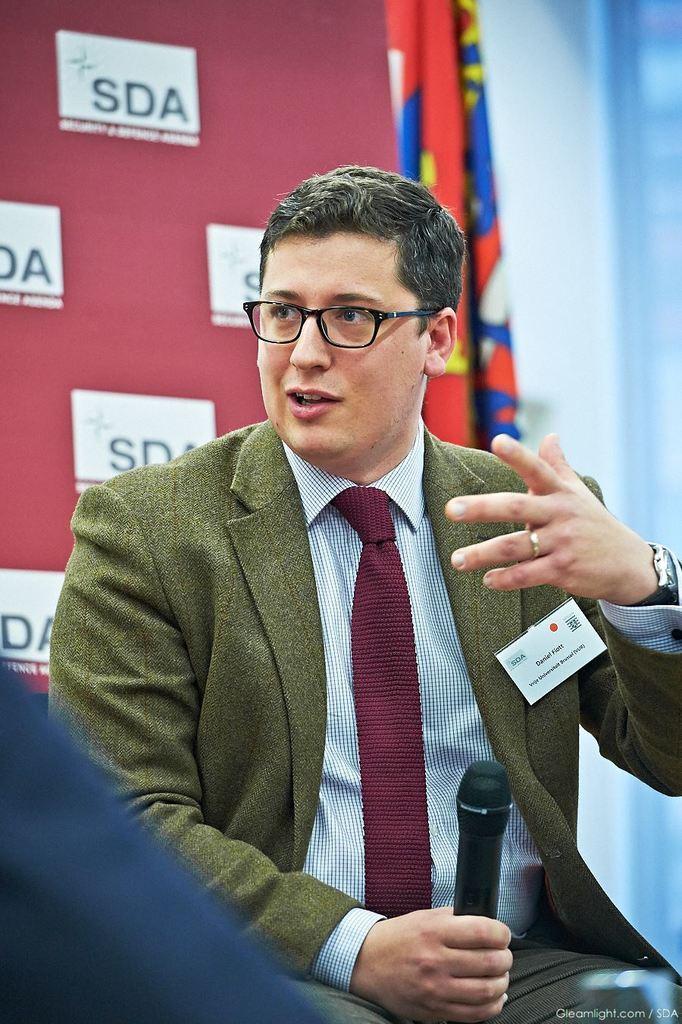Could you give a brief overview of what you see in this image? In the image there is a man holding a microphone and opened his mouth for talking. In background we can see curtains and red color hoarding. 